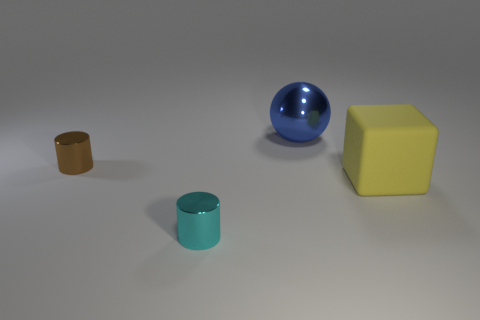Add 2 big cyan metal spheres. How many objects exist? 6 Subtract 1 cylinders. How many cylinders are left? 1 Subtract all brown cylinders. How many cylinders are left? 1 Subtract all cubes. How many objects are left? 3 Subtract all gray cubes. Subtract all yellow cylinders. How many cubes are left? 1 Subtract all cyan cubes. How many brown cylinders are left? 1 Subtract all cyan rubber cylinders. Subtract all large yellow things. How many objects are left? 3 Add 3 small brown shiny cylinders. How many small brown shiny cylinders are left? 4 Add 1 big green spheres. How many big green spheres exist? 1 Subtract 0 yellow cylinders. How many objects are left? 4 